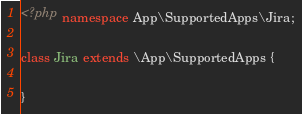Convert code to text. <code><loc_0><loc_0><loc_500><loc_500><_PHP_><?php namespace App\SupportedApps\Jira;

class Jira extends \App\SupportedApps {

}</code> 